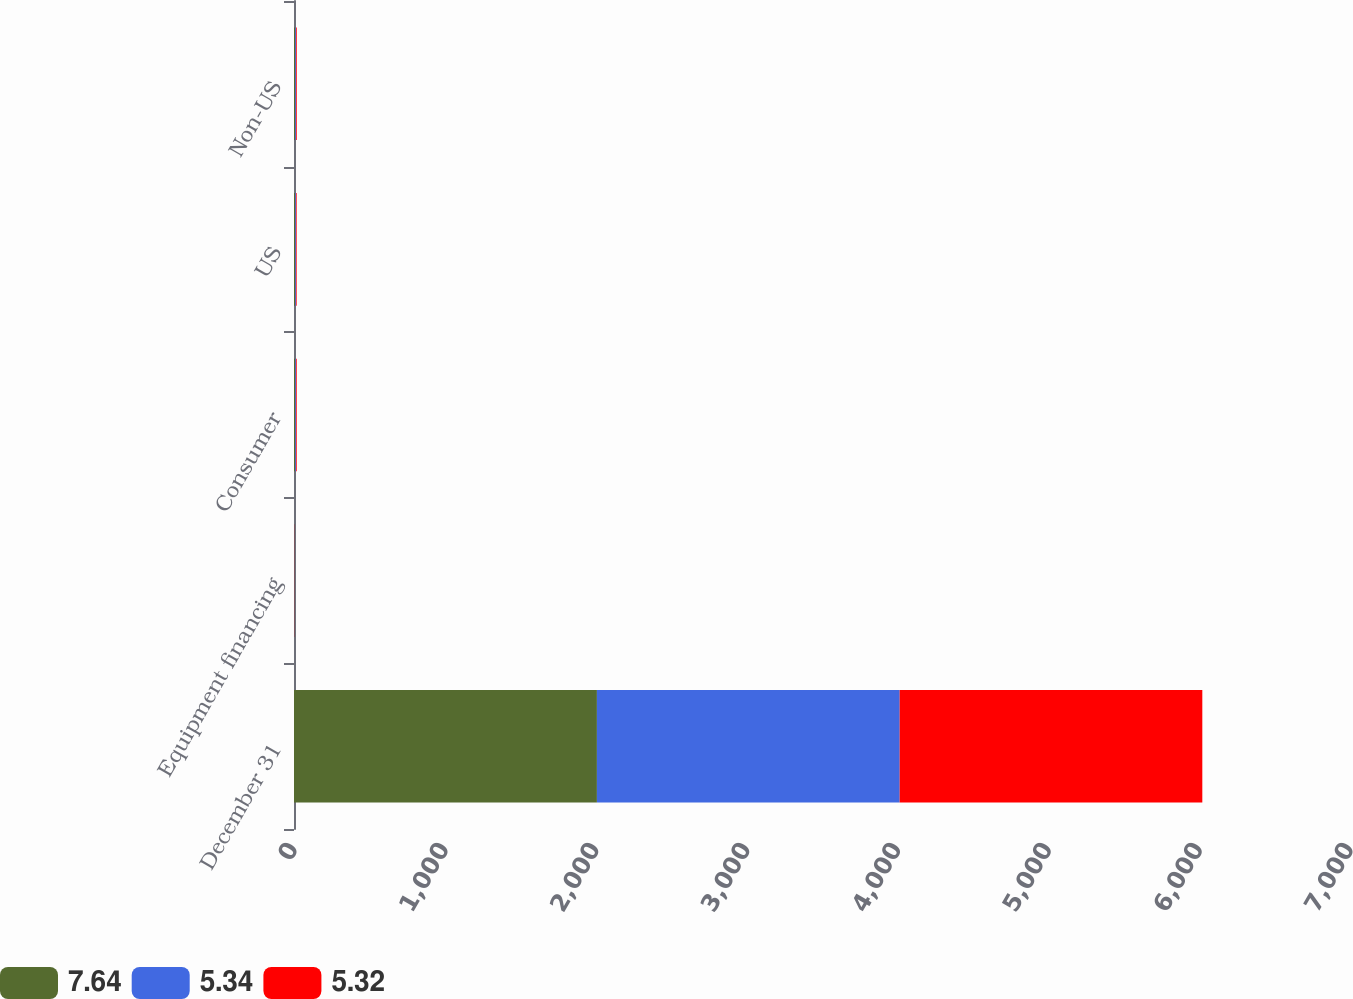Convert chart to OTSL. <chart><loc_0><loc_0><loc_500><loc_500><stacked_bar_chart><ecel><fcel>December 31<fcel>Equipment financing<fcel>Consumer<fcel>US<fcel>Non-US<nl><fcel>7.64<fcel>2008<fcel>2.17<fcel>7.47<fcel>7.14<fcel>7.64<nl><fcel>5.34<fcel>2007<fcel>1.21<fcel>5.38<fcel>5.52<fcel>5.32<nl><fcel>5.32<fcel>2006<fcel>1.22<fcel>5.22<fcel>4.93<fcel>5.34<nl></chart> 